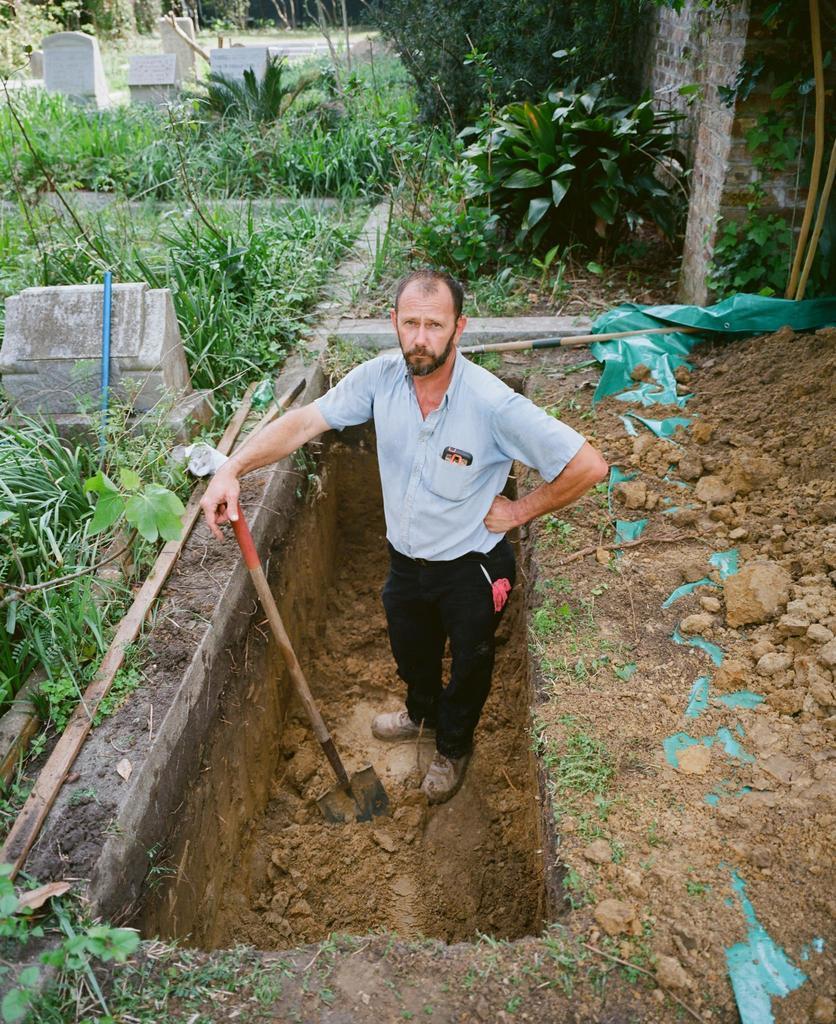Could you give a brief overview of what you see in this image? This picture is clicked outside. In the center there is a person wearing shirt and standing on the ground and there are some objects placed on the ground and we can see the grass and the plants. In the background we can see the wall and some other items. 